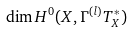Convert formula to latex. <formula><loc_0><loc_0><loc_500><loc_500>\dim H ^ { 0 } ( X , \Gamma ^ { ( l ) } T _ { X } ^ { \ast } )</formula> 